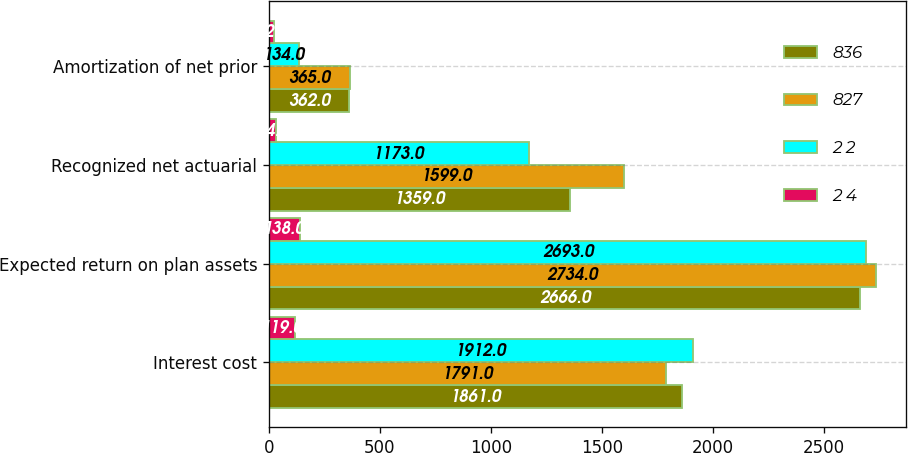<chart> <loc_0><loc_0><loc_500><loc_500><stacked_bar_chart><ecel><fcel>Interest cost<fcel>Expected return on plan assets<fcel>Recognized net actuarial<fcel>Amortization of net prior<nl><fcel>836<fcel>1861<fcel>2666<fcel>1359<fcel>362<nl><fcel>827<fcel>1791<fcel>2734<fcel>1599<fcel>365<nl><fcel>2 2<fcel>1912<fcel>2693<fcel>1173<fcel>134<nl><fcel>2 4<fcel>119<fcel>138<fcel>34<fcel>22<nl></chart> 